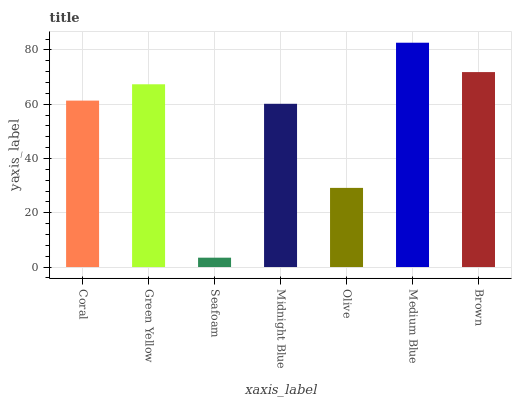Is Seafoam the minimum?
Answer yes or no. Yes. Is Medium Blue the maximum?
Answer yes or no. Yes. Is Green Yellow the minimum?
Answer yes or no. No. Is Green Yellow the maximum?
Answer yes or no. No. Is Green Yellow greater than Coral?
Answer yes or no. Yes. Is Coral less than Green Yellow?
Answer yes or no. Yes. Is Coral greater than Green Yellow?
Answer yes or no. No. Is Green Yellow less than Coral?
Answer yes or no. No. Is Coral the high median?
Answer yes or no. Yes. Is Coral the low median?
Answer yes or no. Yes. Is Olive the high median?
Answer yes or no. No. Is Green Yellow the low median?
Answer yes or no. No. 